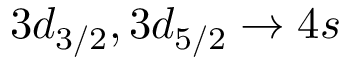Convert formula to latex. <formula><loc_0><loc_0><loc_500><loc_500>3 d _ { 3 / 2 } , 3 d _ { 5 / 2 } \rightarrow 4 s</formula> 